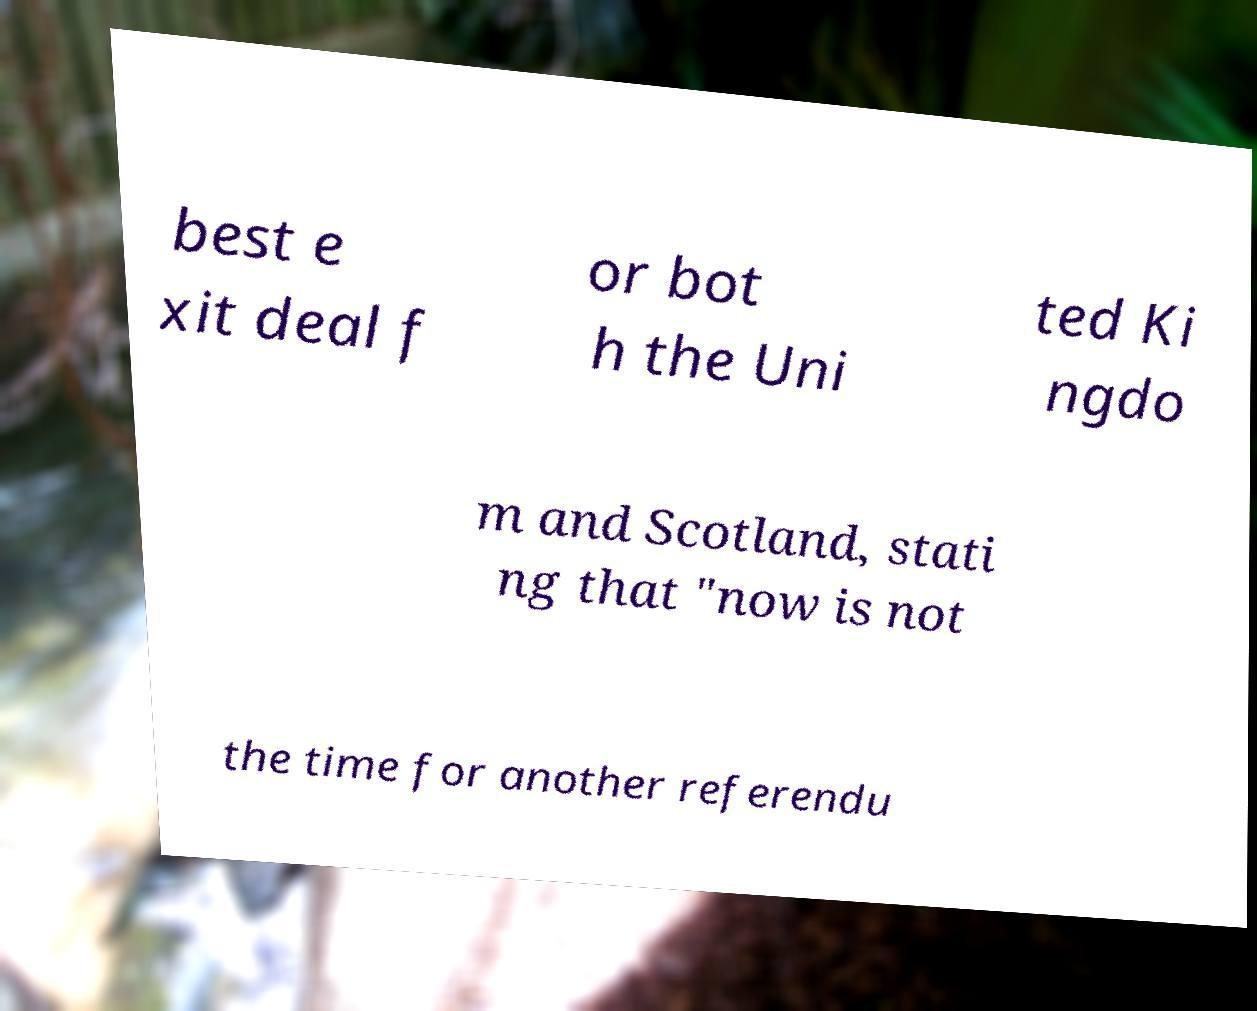Please read and relay the text visible in this image. What does it say? best e xit deal f or bot h the Uni ted Ki ngdo m and Scotland, stati ng that "now is not the time for another referendu 